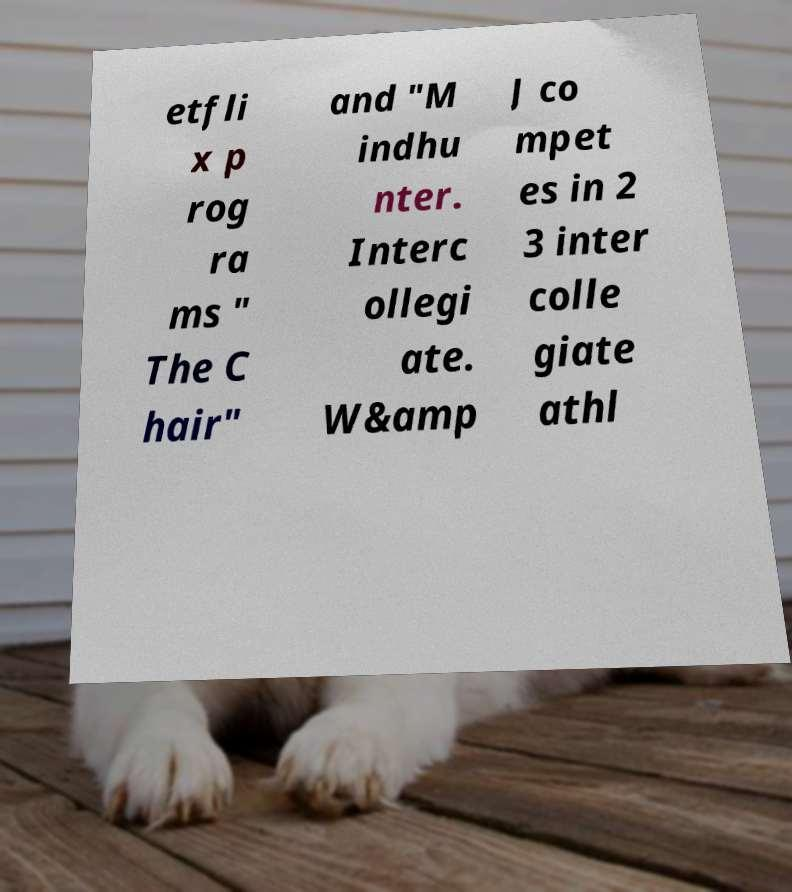Could you assist in decoding the text presented in this image and type it out clearly? etfli x p rog ra ms " The C hair" and "M indhu nter. Interc ollegi ate. W&amp J co mpet es in 2 3 inter colle giate athl 